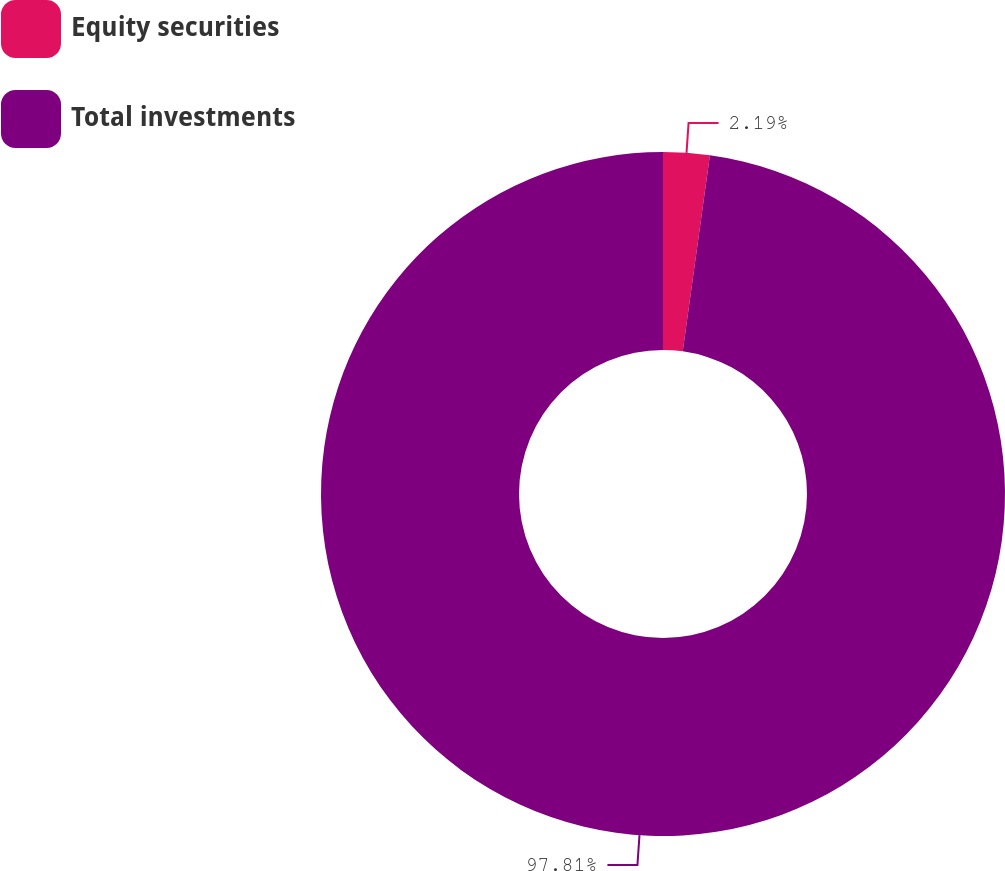<chart> <loc_0><loc_0><loc_500><loc_500><pie_chart><fcel>Equity securities<fcel>Total investments<nl><fcel>2.19%<fcel>97.81%<nl></chart> 